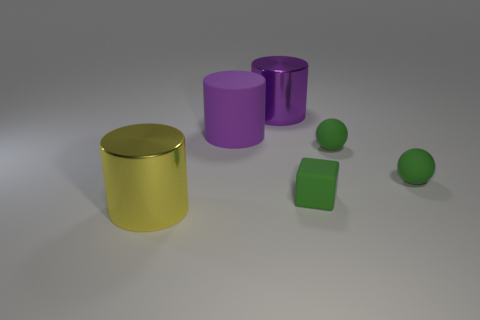How many cubes are there?
Make the answer very short. 1. What is the shape of the large thing that is the same color as the big rubber cylinder?
Give a very brief answer. Cylinder. What is the size of the yellow metal thing that is the same shape as the large purple metallic object?
Offer a terse response. Large. Is the shape of the shiny thing in front of the purple metal thing the same as  the big rubber thing?
Give a very brief answer. Yes. There is a large metal cylinder in front of the green matte block; what color is it?
Give a very brief answer. Yellow. What number of other things are there of the same size as the purple rubber cylinder?
Offer a very short reply. 2. Is there anything else that is the same shape as the purple metal object?
Your answer should be very brief. Yes. Is the number of green matte objects that are to the left of the big purple rubber object the same as the number of large purple rubber objects?
Keep it short and to the point. No. How many other tiny green cubes have the same material as the tiny green cube?
Make the answer very short. 0. There is a large cylinder that is the same material as the green block; what is its color?
Make the answer very short. Purple. 